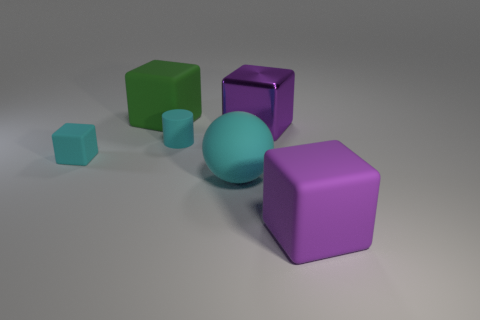Subtract all blue cubes. Subtract all green balls. How many cubes are left? 4 Add 2 cyan balls. How many objects exist? 8 Subtract all balls. How many objects are left? 5 Subtract 0 gray spheres. How many objects are left? 6 Subtract all tiny cyan objects. Subtract all tiny cyan matte cubes. How many objects are left? 3 Add 2 large purple matte cubes. How many large purple matte cubes are left? 3 Add 6 small red rubber blocks. How many small red rubber blocks exist? 6 